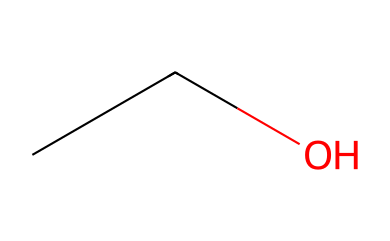What is the name of this chemical? The SMILES representation "CCO" corresponds to ethanol, which is commonly known as ethyl alcohol.
Answer: ethanol How many carbon atoms are in this structure? The SMILES "CCO" indicates there are two "C" characters, meaning there are two carbon atoms in the molecule.
Answer: 2 What type of functional group does this chemical have? Ethanol contains a hydroxyl group (-OH) as indicated by the presence of "O" after the carbon chain, which classifies it as an alcohol.
Answer: alcohol How many hydrogen atoms are present in this chemical? Each carbon in "CC" typically bonds with enough hydrogen atoms to fulfill the tetravalent nature of carbon. In this case, there are 6 hydrogen atoms (C2H6O).
Answer: 6 Does this chemical have any double bonds? There are no double bonds present in the SMILES representation; both carbon atoms are connected by single bonds, and the oxygen is also connected by a single bond to the carbon.
Answer: no What is the hybridization of the carbon atoms in this chemical? The two carbon atoms are sp3 hybridized due to the four single bonds formed - two with hydrogen and one with the other carbon, and one with oxygen.
Answer: sp3 Is this chemical a primary or secondary alcohol? The alcohol functional group (-OH) is attached to a carbon that is attached to only one other carbon; thus, it is classified as a primary alcohol.
Answer: primary 